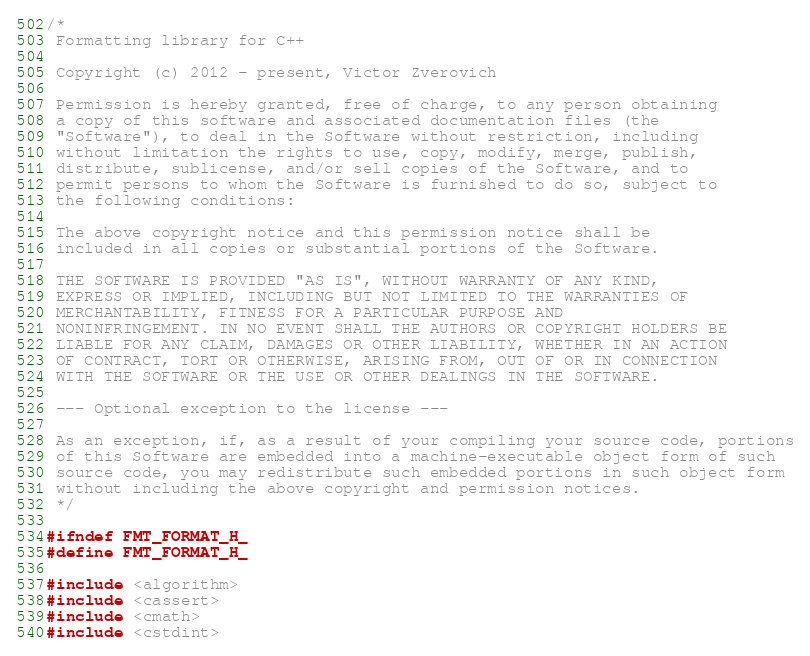<code> <loc_0><loc_0><loc_500><loc_500><_C_>/*
 Formatting library for C++

 Copyright (c) 2012 - present, Victor Zverovich

 Permission is hereby granted, free of charge, to any person obtaining
 a copy of this software and associated documentation files (the
 "Software"), to deal in the Software without restriction, including
 without limitation the rights to use, copy, modify, merge, publish,
 distribute, sublicense, and/or sell copies of the Software, and to
 permit persons to whom the Software is furnished to do so, subject to
 the following conditions:

 The above copyright notice and this permission notice shall be
 included in all copies or substantial portions of the Software.

 THE SOFTWARE IS PROVIDED "AS IS", WITHOUT WARRANTY OF ANY KIND,
 EXPRESS OR IMPLIED, INCLUDING BUT NOT LIMITED TO THE WARRANTIES OF
 MERCHANTABILITY, FITNESS FOR A PARTICULAR PURPOSE AND
 NONINFRINGEMENT. IN NO EVENT SHALL THE AUTHORS OR COPYRIGHT HOLDERS BE
 LIABLE FOR ANY CLAIM, DAMAGES OR OTHER LIABILITY, WHETHER IN AN ACTION
 OF CONTRACT, TORT OR OTHERWISE, ARISING FROM, OUT OF OR IN CONNECTION
 WITH THE SOFTWARE OR THE USE OR OTHER DEALINGS IN THE SOFTWARE.

 --- Optional exception to the license ---

 As an exception, if, as a result of your compiling your source code, portions
 of this Software are embedded into a machine-executable object form of such
 source code, you may redistribute such embedded portions in such object form
 without including the above copyright and permission notices.
 */

#ifndef FMT_FORMAT_H_
#define FMT_FORMAT_H_

#include <algorithm>
#include <cassert>
#include <cmath>
#include <cstdint></code> 